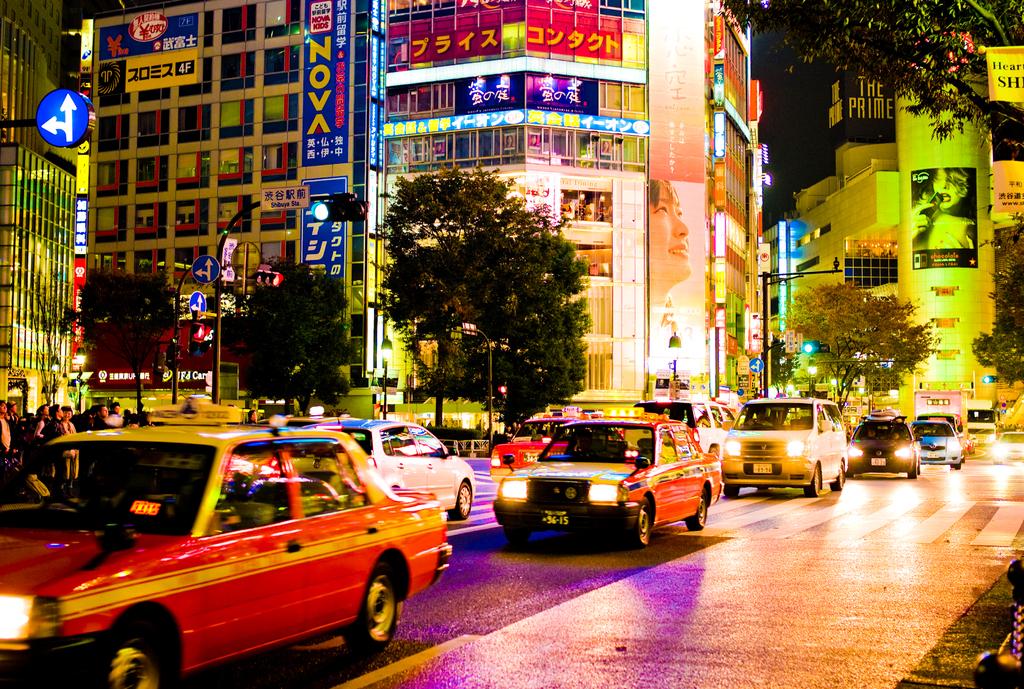What word is written in yellow font on the blue sign?
Offer a terse response. Nova. 